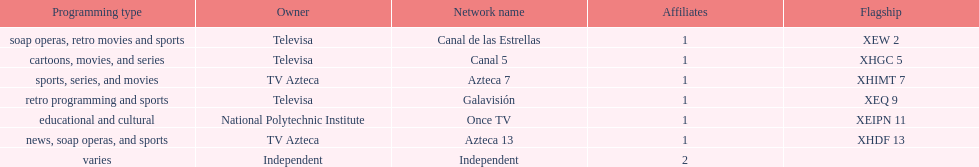Azteca 7 and azteca 13 are both owned by whom? TV Azteca. 